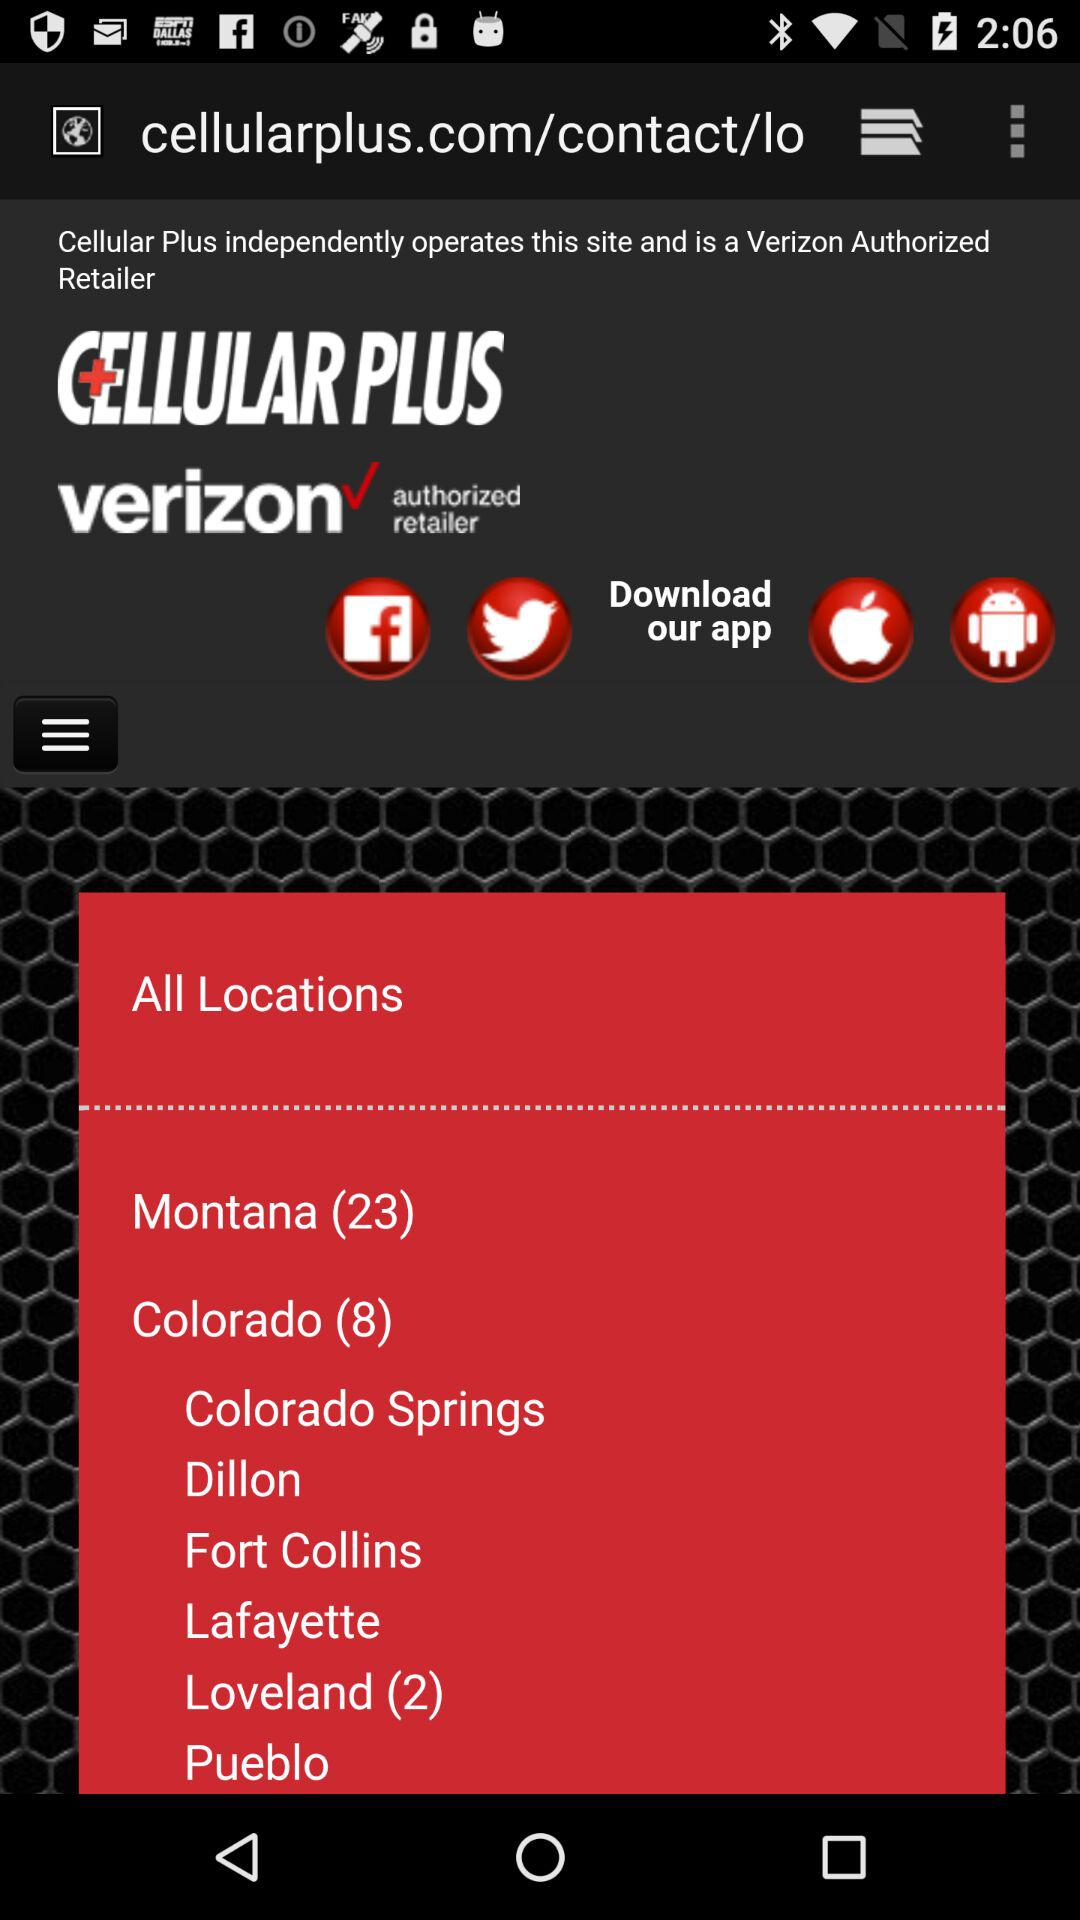What is the application name? The name of the application is "Cellular Plus". 